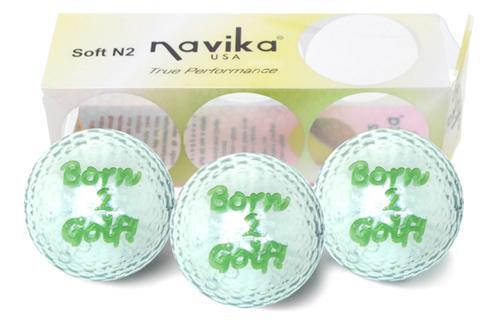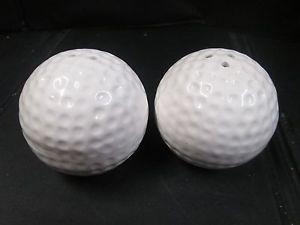The first image is the image on the left, the second image is the image on the right. For the images shown, is this caption "The balls in at least one of the images are set on the grass." true? Answer yes or no. No. 